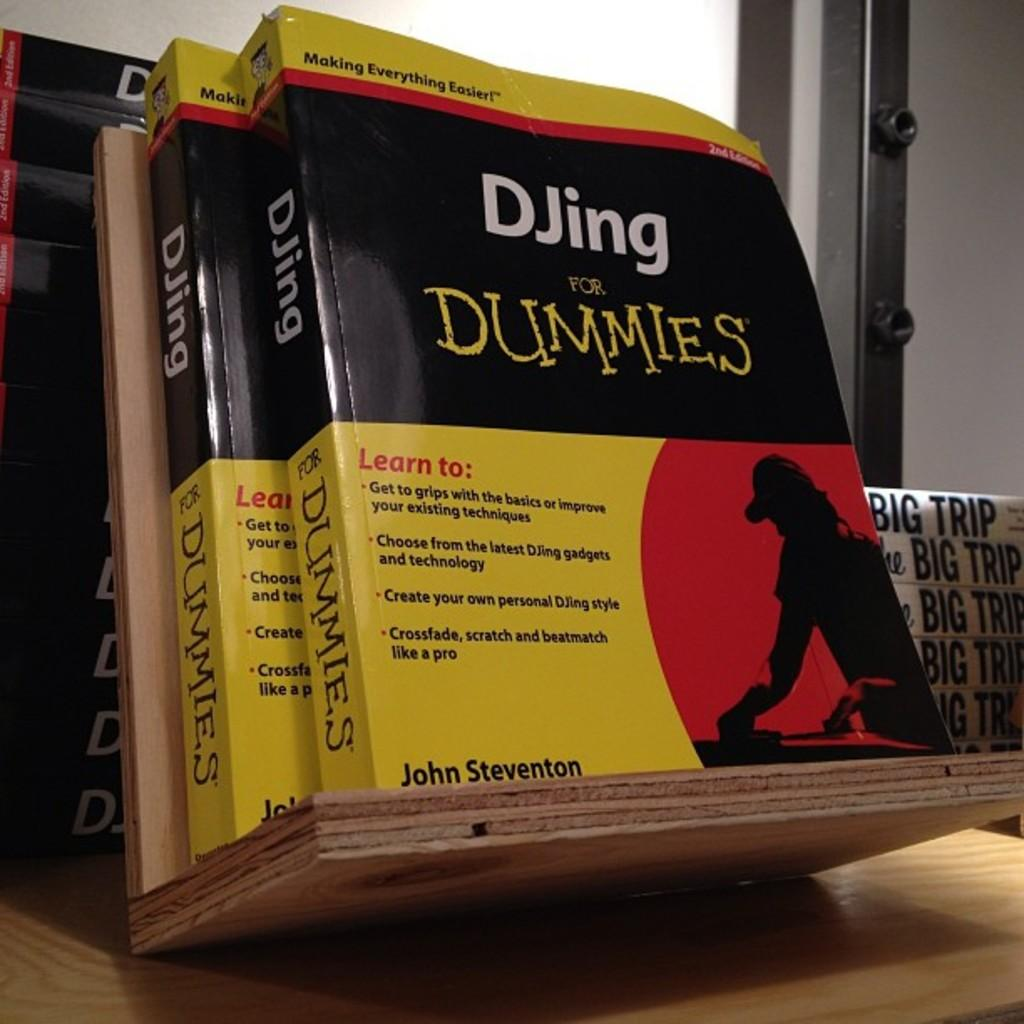<image>
Write a terse but informative summary of the picture. Two books called DJing for Dummies by John Steventon are displayed. 